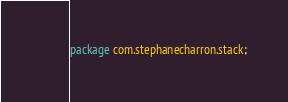Convert code to text. <code><loc_0><loc_0><loc_500><loc_500><_Java_>package com.stephanecharron.stack;
</code> 